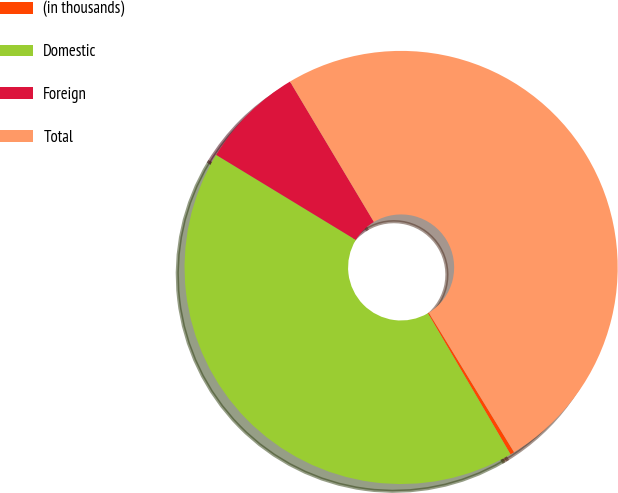<chart> <loc_0><loc_0><loc_500><loc_500><pie_chart><fcel>(in thousands)<fcel>Domestic<fcel>Foreign<fcel>Total<nl><fcel>0.31%<fcel>42.13%<fcel>7.72%<fcel>49.84%<nl></chart> 